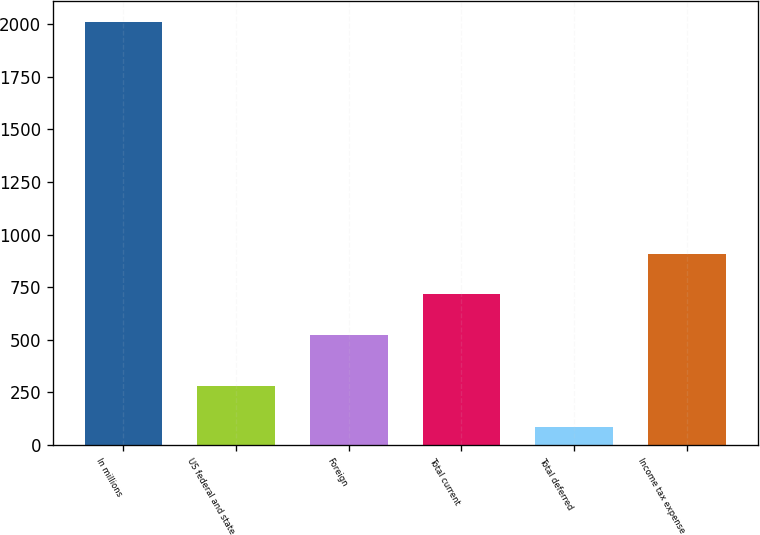<chart> <loc_0><loc_0><loc_500><loc_500><bar_chart><fcel>In millions<fcel>US federal and state<fcel>Foreign<fcel>Total current<fcel>Total deferred<fcel>Income tax expense<nl><fcel>2011<fcel>277.6<fcel>524<fcel>716.6<fcel>85<fcel>909.2<nl></chart> 